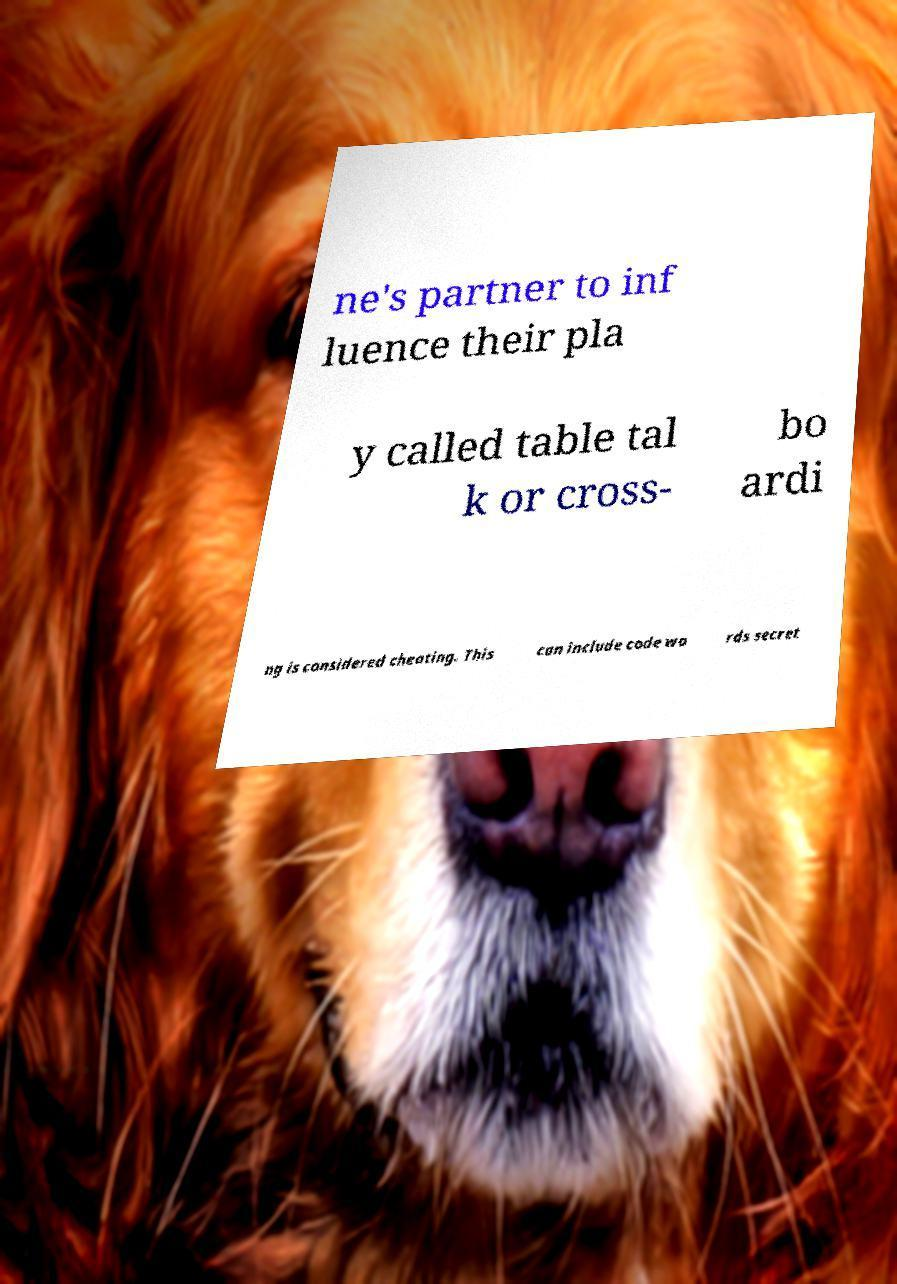Can you read and provide the text displayed in the image?This photo seems to have some interesting text. Can you extract and type it out for me? ne's partner to inf luence their pla y called table tal k or cross- bo ardi ng is considered cheating. This can include code wo rds secret 